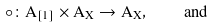<formula> <loc_0><loc_0><loc_500><loc_500>\circ \colon A _ { [ 1 ] } \times A _ { X } \rightarrow A _ { X } , \quad a n d</formula> 